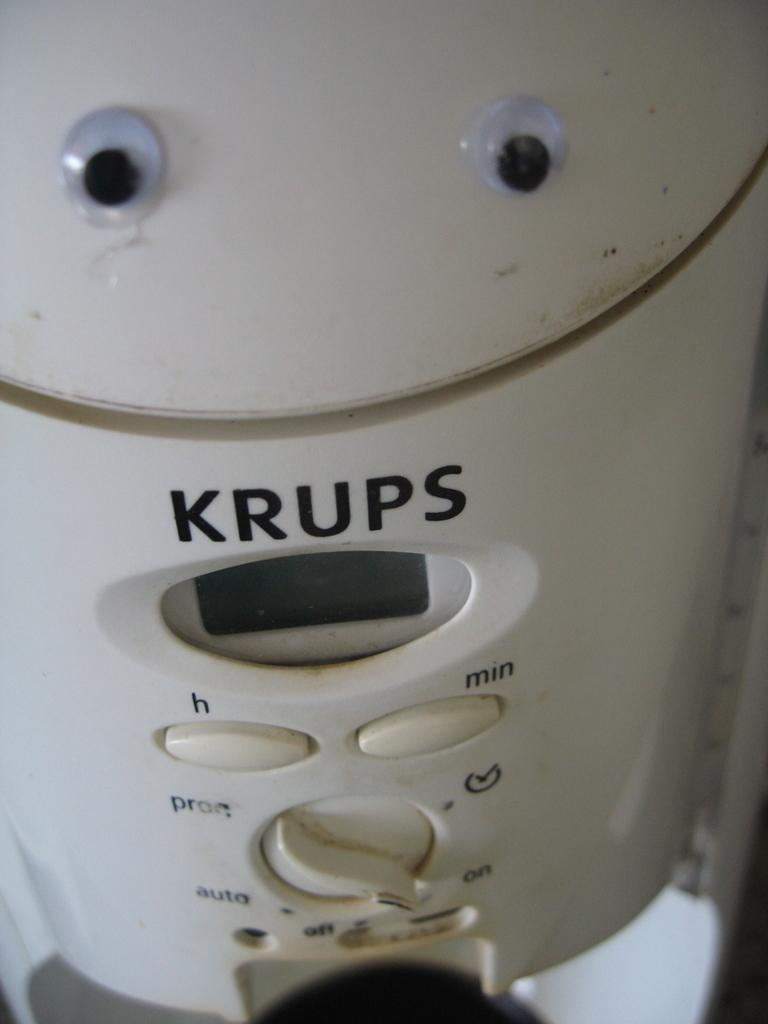Provide a one-sentence caption for the provided image. A white KRUPS device with H and Min buttons and a deal for on/off/auto. 